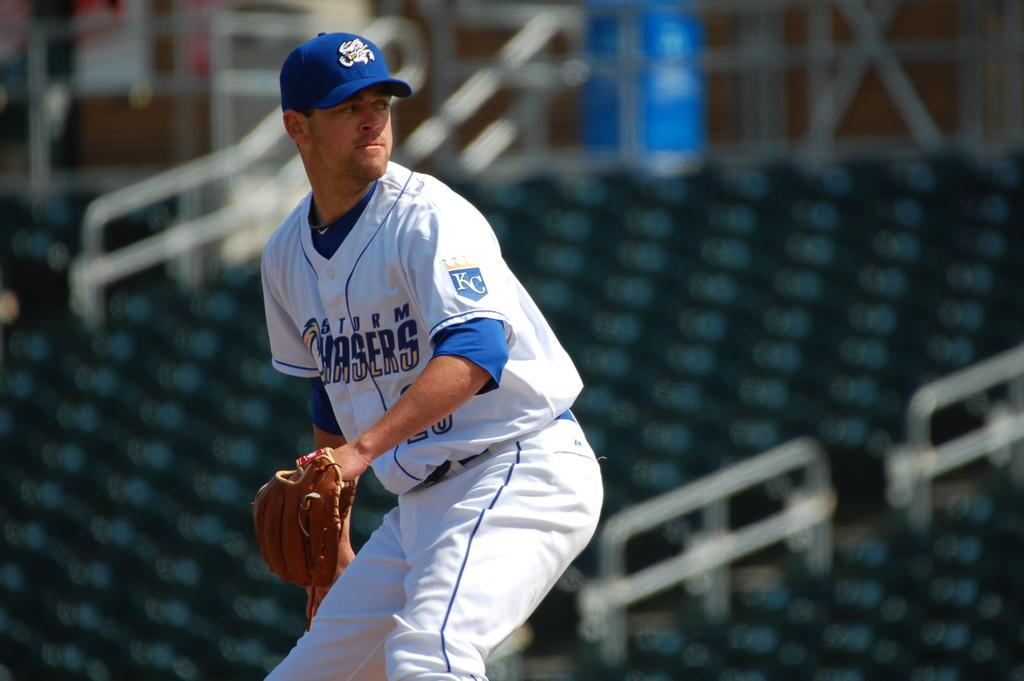<image>
Present a compact description of the photo's key features. A baseball player wearing a jersey depicting Storm Chasers stands on the field. 